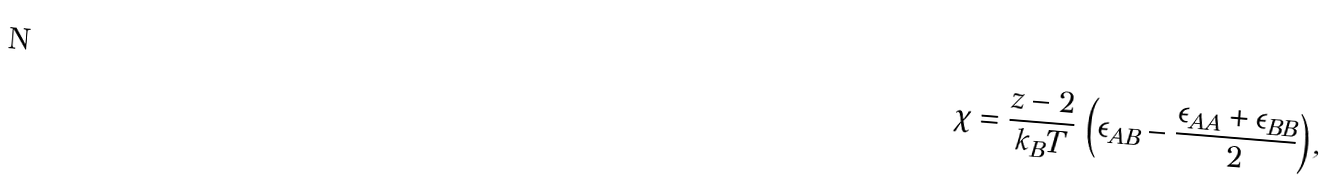<formula> <loc_0><loc_0><loc_500><loc_500>\chi = \frac { z - 2 } { k _ { B } T } \, \left ( \epsilon _ { A B } - \frac { \epsilon _ { A A } + \epsilon _ { B B } } { 2 } \right ) ,</formula> 